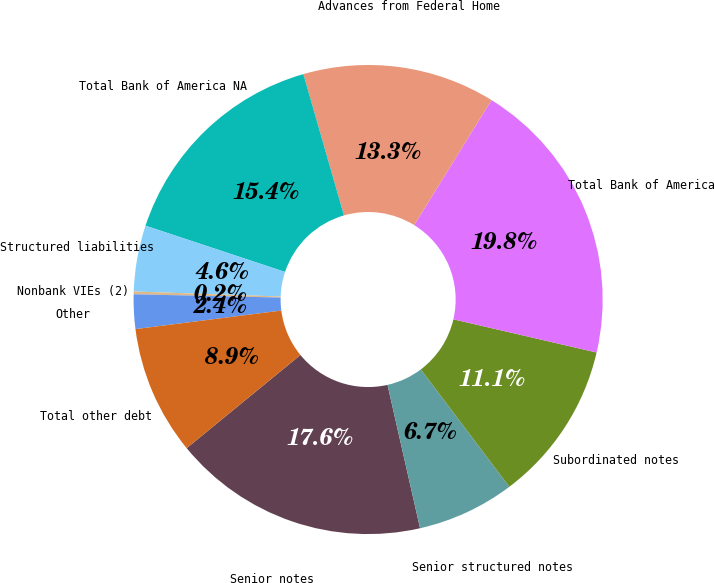Convert chart to OTSL. <chart><loc_0><loc_0><loc_500><loc_500><pie_chart><fcel>Senior notes<fcel>Senior structured notes<fcel>Subordinated notes<fcel>Total Bank of America<fcel>Advances from Federal Home<fcel>Total Bank of America NA<fcel>Structured liabilities<fcel>Nonbank VIEs (2)<fcel>Other<fcel>Total other debt<nl><fcel>17.63%<fcel>6.73%<fcel>11.09%<fcel>19.81%<fcel>13.27%<fcel>15.45%<fcel>4.55%<fcel>0.19%<fcel>2.37%<fcel>8.91%<nl></chart> 